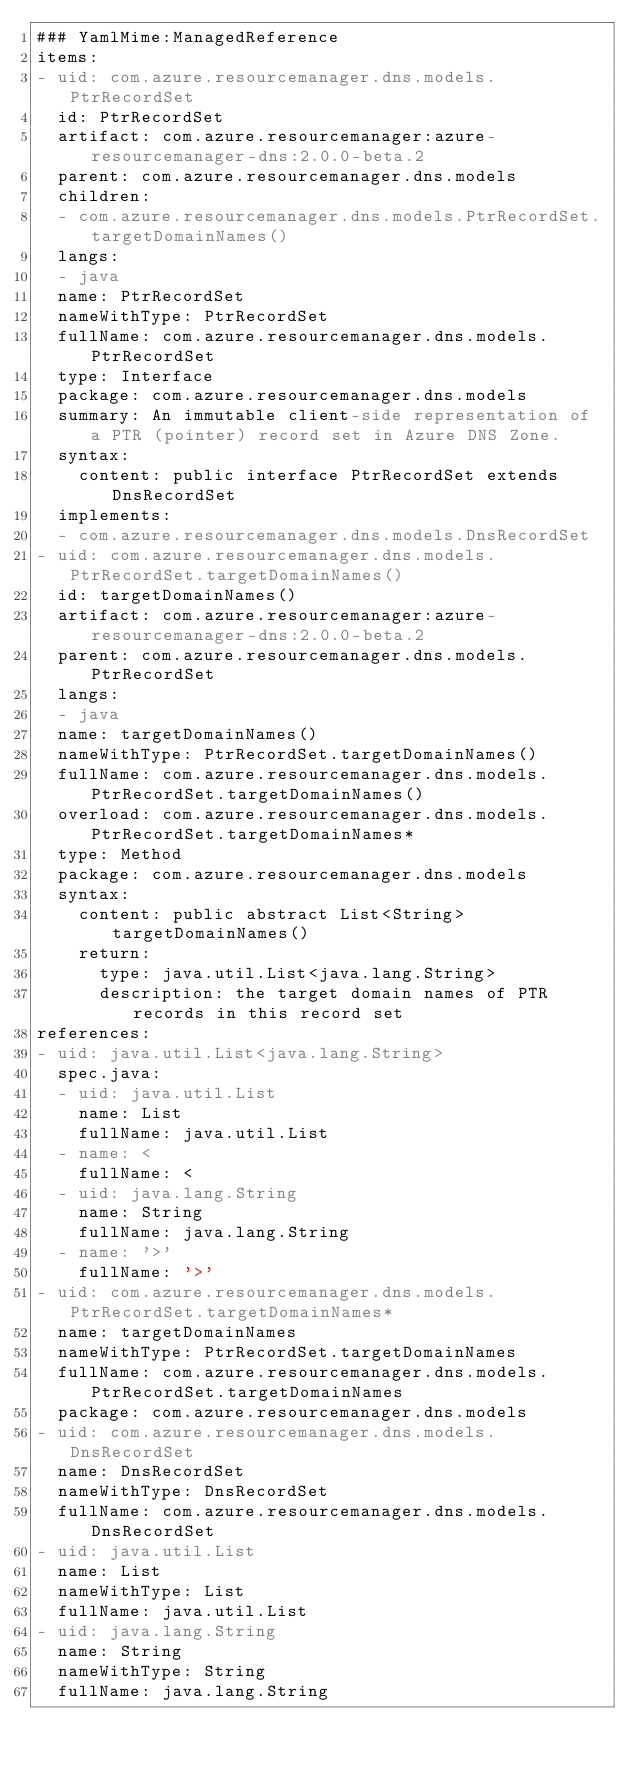<code> <loc_0><loc_0><loc_500><loc_500><_YAML_>### YamlMime:ManagedReference
items:
- uid: com.azure.resourcemanager.dns.models.PtrRecordSet
  id: PtrRecordSet
  artifact: com.azure.resourcemanager:azure-resourcemanager-dns:2.0.0-beta.2
  parent: com.azure.resourcemanager.dns.models
  children:
  - com.azure.resourcemanager.dns.models.PtrRecordSet.targetDomainNames()
  langs:
  - java
  name: PtrRecordSet
  nameWithType: PtrRecordSet
  fullName: com.azure.resourcemanager.dns.models.PtrRecordSet
  type: Interface
  package: com.azure.resourcemanager.dns.models
  summary: An immutable client-side representation of a PTR (pointer) record set in Azure DNS Zone.
  syntax:
    content: public interface PtrRecordSet extends DnsRecordSet
  implements:
  - com.azure.resourcemanager.dns.models.DnsRecordSet
- uid: com.azure.resourcemanager.dns.models.PtrRecordSet.targetDomainNames()
  id: targetDomainNames()
  artifact: com.azure.resourcemanager:azure-resourcemanager-dns:2.0.0-beta.2
  parent: com.azure.resourcemanager.dns.models.PtrRecordSet
  langs:
  - java
  name: targetDomainNames()
  nameWithType: PtrRecordSet.targetDomainNames()
  fullName: com.azure.resourcemanager.dns.models.PtrRecordSet.targetDomainNames()
  overload: com.azure.resourcemanager.dns.models.PtrRecordSet.targetDomainNames*
  type: Method
  package: com.azure.resourcemanager.dns.models
  syntax:
    content: public abstract List<String> targetDomainNames()
    return:
      type: java.util.List<java.lang.String>
      description: the target domain names of PTR records in this record set
references:
- uid: java.util.List<java.lang.String>
  spec.java:
  - uid: java.util.List
    name: List
    fullName: java.util.List
  - name: <
    fullName: <
  - uid: java.lang.String
    name: String
    fullName: java.lang.String
  - name: '>'
    fullName: '>'
- uid: com.azure.resourcemanager.dns.models.PtrRecordSet.targetDomainNames*
  name: targetDomainNames
  nameWithType: PtrRecordSet.targetDomainNames
  fullName: com.azure.resourcemanager.dns.models.PtrRecordSet.targetDomainNames
  package: com.azure.resourcemanager.dns.models
- uid: com.azure.resourcemanager.dns.models.DnsRecordSet
  name: DnsRecordSet
  nameWithType: DnsRecordSet
  fullName: com.azure.resourcemanager.dns.models.DnsRecordSet
- uid: java.util.List
  name: List
  nameWithType: List
  fullName: java.util.List
- uid: java.lang.String
  name: String
  nameWithType: String
  fullName: java.lang.String
</code> 